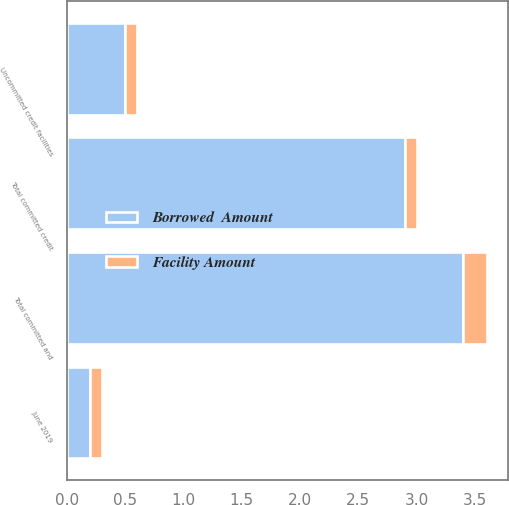Convert chart to OTSL. <chart><loc_0><loc_0><loc_500><loc_500><stacked_bar_chart><ecel><fcel>June 2019<fcel>Total committed credit<fcel>Uncommitted credit facilities<fcel>Total committed and<nl><fcel>Borrowed  Amount<fcel>0.2<fcel>2.9<fcel>0.5<fcel>3.4<nl><fcel>Facility Amount<fcel>0.1<fcel>0.1<fcel>0.1<fcel>0.2<nl></chart> 